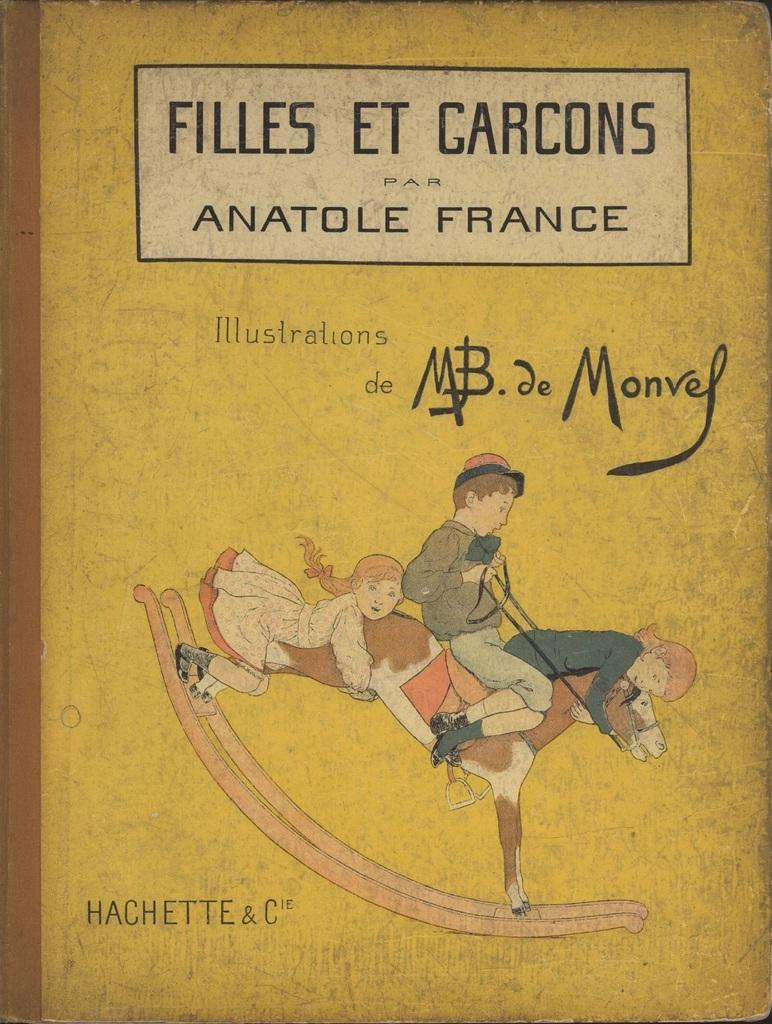Provide a one-sentence caption for the provided image. Filles et garcons par anatole france book illustrations de mb de monvey. 